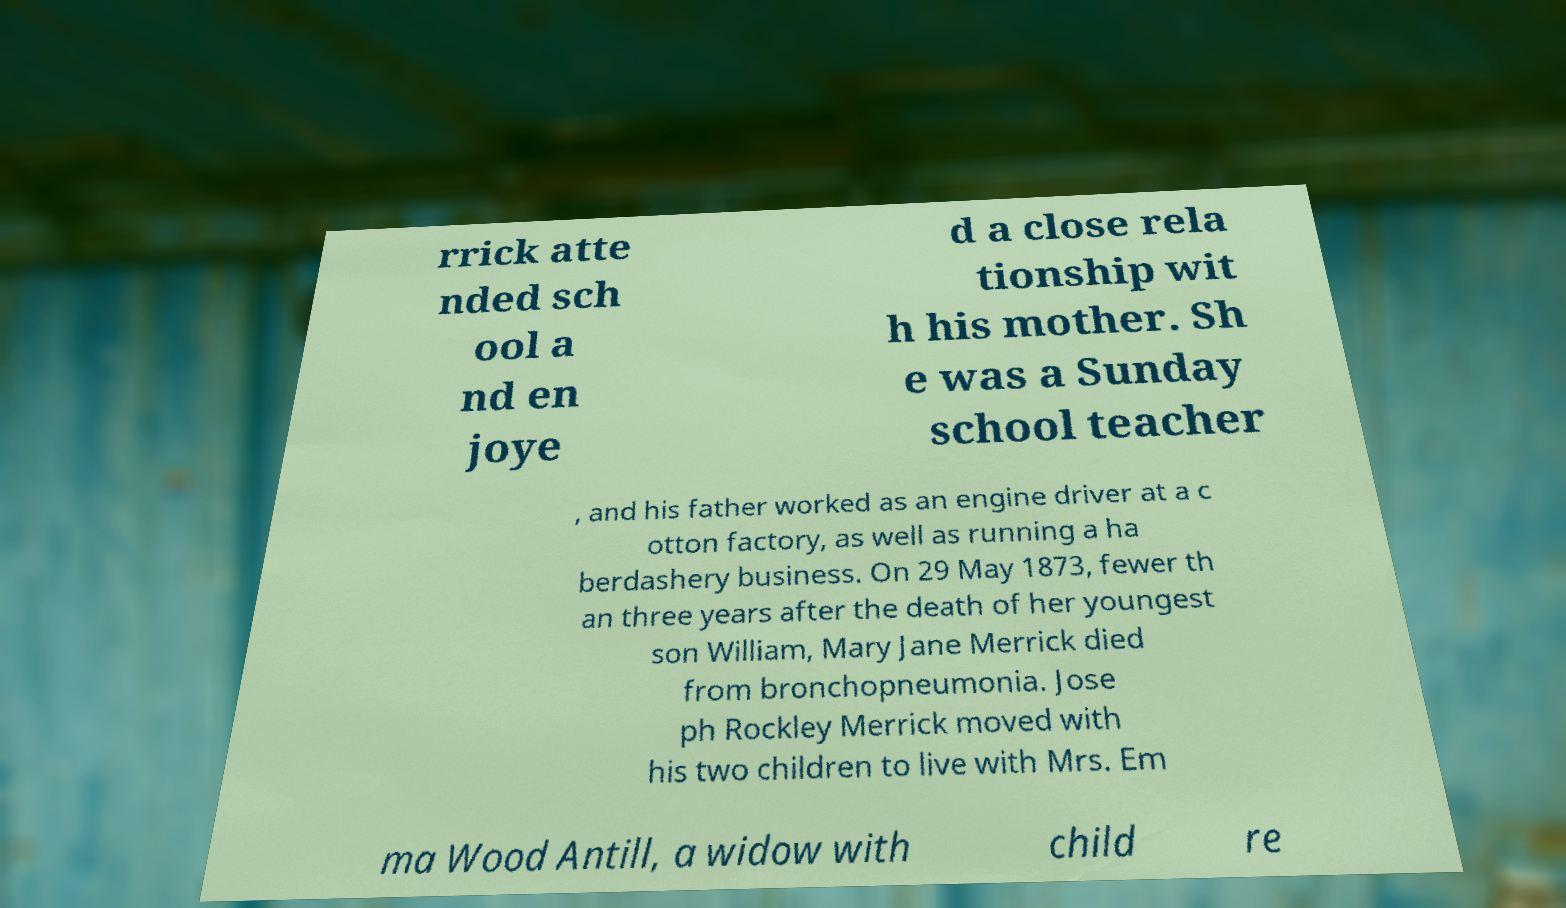For documentation purposes, I need the text within this image transcribed. Could you provide that? rrick atte nded sch ool a nd en joye d a close rela tionship wit h his mother. Sh e was a Sunday school teacher , and his father worked as an engine driver at a c otton factory, as well as running a ha berdashery business. On 29 May 1873, fewer th an three years after the death of her youngest son William, Mary Jane Merrick died from bronchopneumonia. Jose ph Rockley Merrick moved with his two children to live with Mrs. Em ma Wood Antill, a widow with child re 